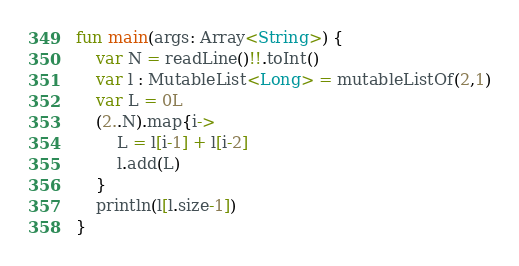<code> <loc_0><loc_0><loc_500><loc_500><_Kotlin_>fun main(args: Array<String>) {
    var N = readLine()!!.toInt()
    var l : MutableList<Long> = mutableListOf(2,1)
    var L = 0L
    (2..N).map{i->
        L = l[i-1] + l[i-2]
        l.add(L)
    }
    println(l[l.size-1])
}
</code> 